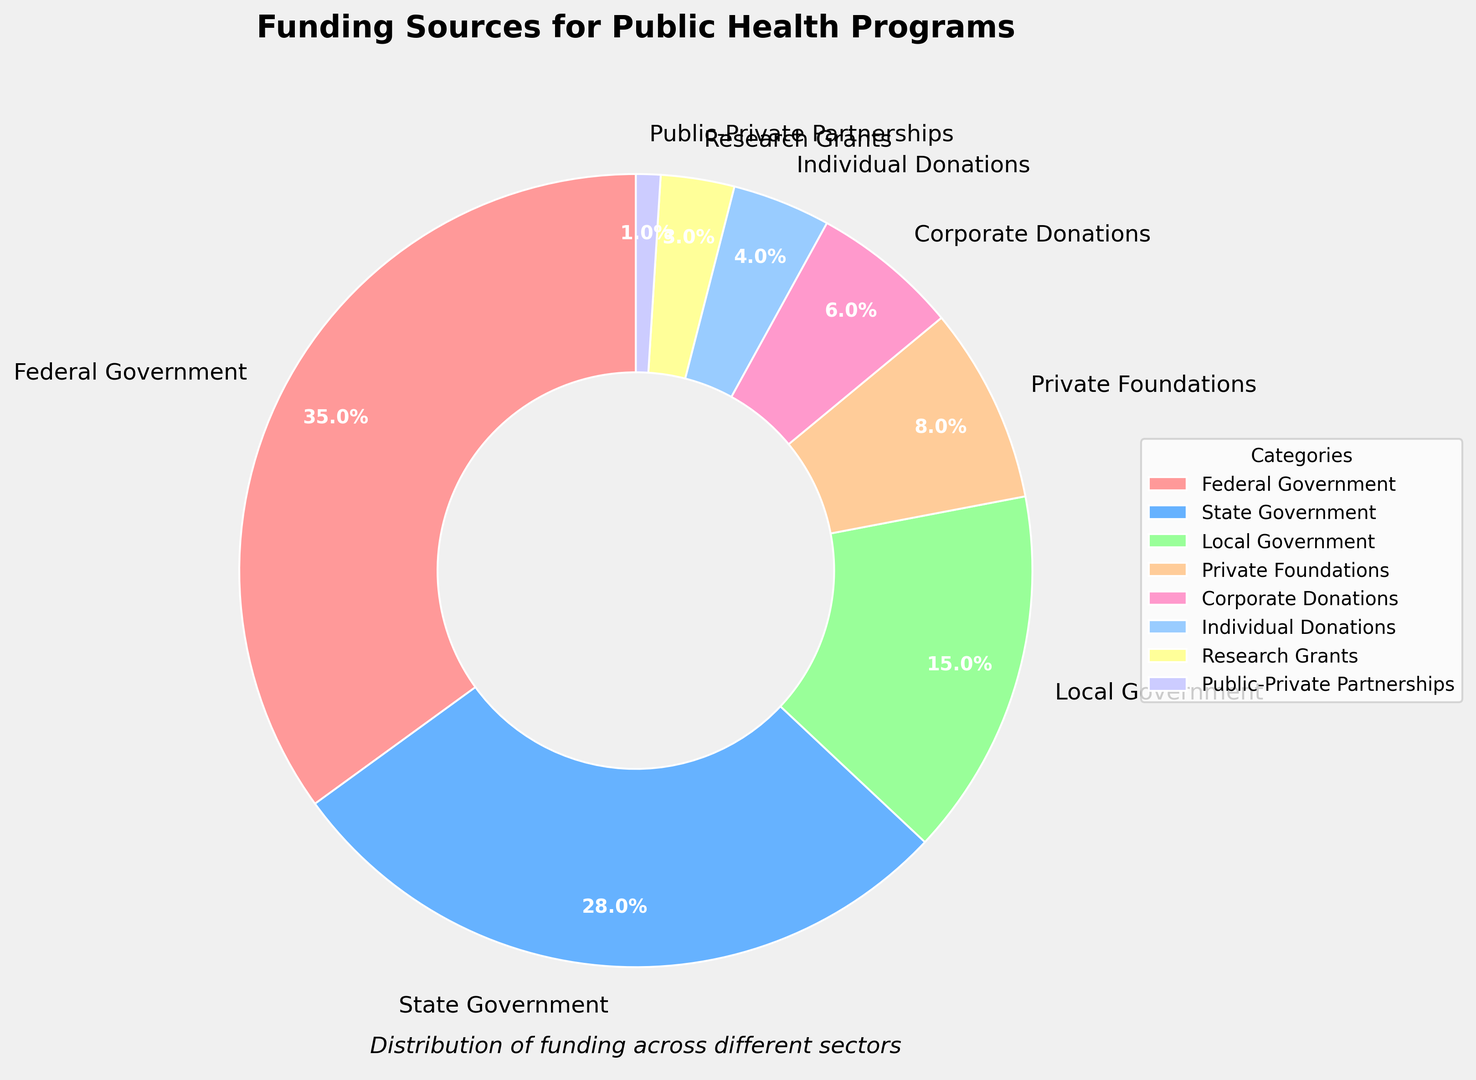Which funding source contributes the most to public health programs? The Federal Government slice is the largest portion of the pie chart, indicating it has the highest percentage.
Answer: Federal Government Which funding sources have a similar contribution percentage? The State Government and Local Government slices are closest in size, indicating similar contributions of 28% and 15%, respectively.
Answer: State Government and Local Government What is the combined contribution percentage of Corporate Donations and Individual Donations? The Corporate Donations percentage is 6% and the Individual Donations percentage is 4%. Adding these together, we get 6% + 4% = 10%.
Answer: 10% Which category has the smallest contribution, and what is its percentage? The Public-Private Partnerships slice is the smallest, indicating the lowest contribution. Its percentage is 1%.
Answer: Public-Private Partnerships, 1% How much more does the Federal Government contribute compared to the State Government? The Federal Government contributes 35%, and the State Government contributes 28%. The difference is 35% - 28% = 7%.
Answer: 7% Among Private Foundations, Corporate Donations, and Individual Donations, which category contributes the least and by how much? The percentages are Private Foundations (8%), Corporate Donations (6%), and Individual Donations (4%). Individual Donations have the smallest percentage. The difference between Individual Donations and Corporate Donations is 6% - 4% = 2%, and the difference between Individual Donations and Private Foundations is 8% - 4% = 4%. Therefore, Individual Donations contribute the least by 2% and 4% compared to Corporate Donations and Private Foundations, respectively.
Answer: Individual Donations, 2% and 4% If you combine the contributions from all levels of government (Federal, State, Local), what is the total percentage? Adding the contributions of Federal Government (35%), State Government (28%), and Local Government (15%), we get 35% + 28% + 15% = 78%.
Answer: 78% Which funding source has the second smallest contribution, and what is its percentage? The second smallest slice corresponds to Research Grants, with a percentage of 3%.
Answer: Research Grants, 3% How does the contribution from Private Foundations compare to that from Research Grants? Private Foundations contribute 8% and Research Grants contribute 3%. Private Foundations contribute 8% - 3% = 5% more than Research Grants.
Answer: Private Foundations contribute 5% more 